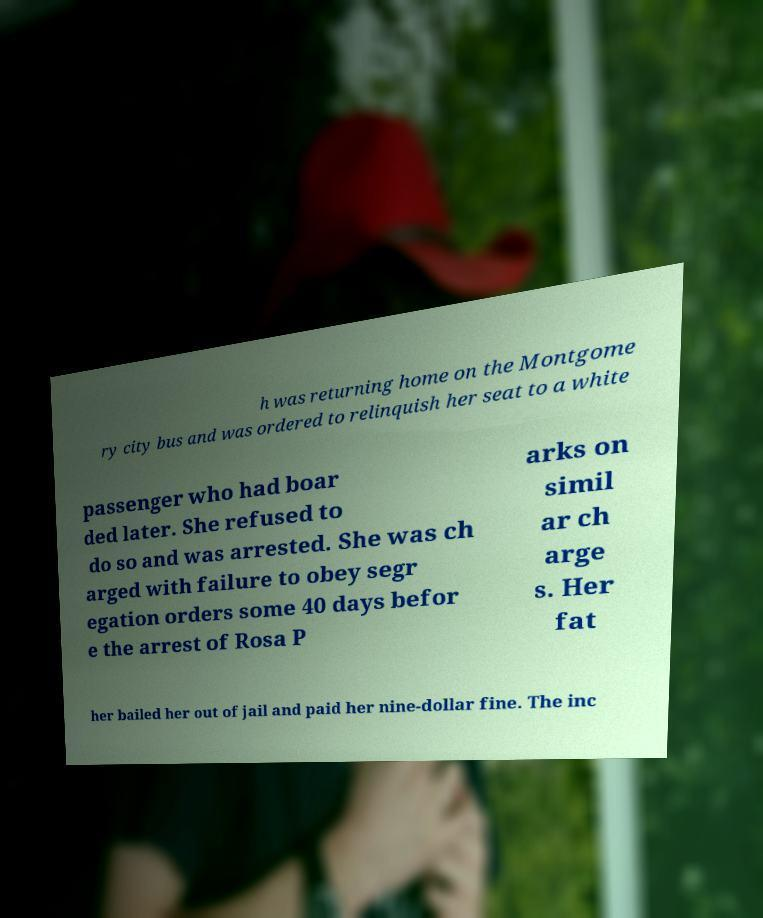Can you accurately transcribe the text from the provided image for me? h was returning home on the Montgome ry city bus and was ordered to relinquish her seat to a white passenger who had boar ded later. She refused to do so and was arrested. She was ch arged with failure to obey segr egation orders some 40 days befor e the arrest of Rosa P arks on simil ar ch arge s. Her fat her bailed her out of jail and paid her nine-dollar fine. The inc 